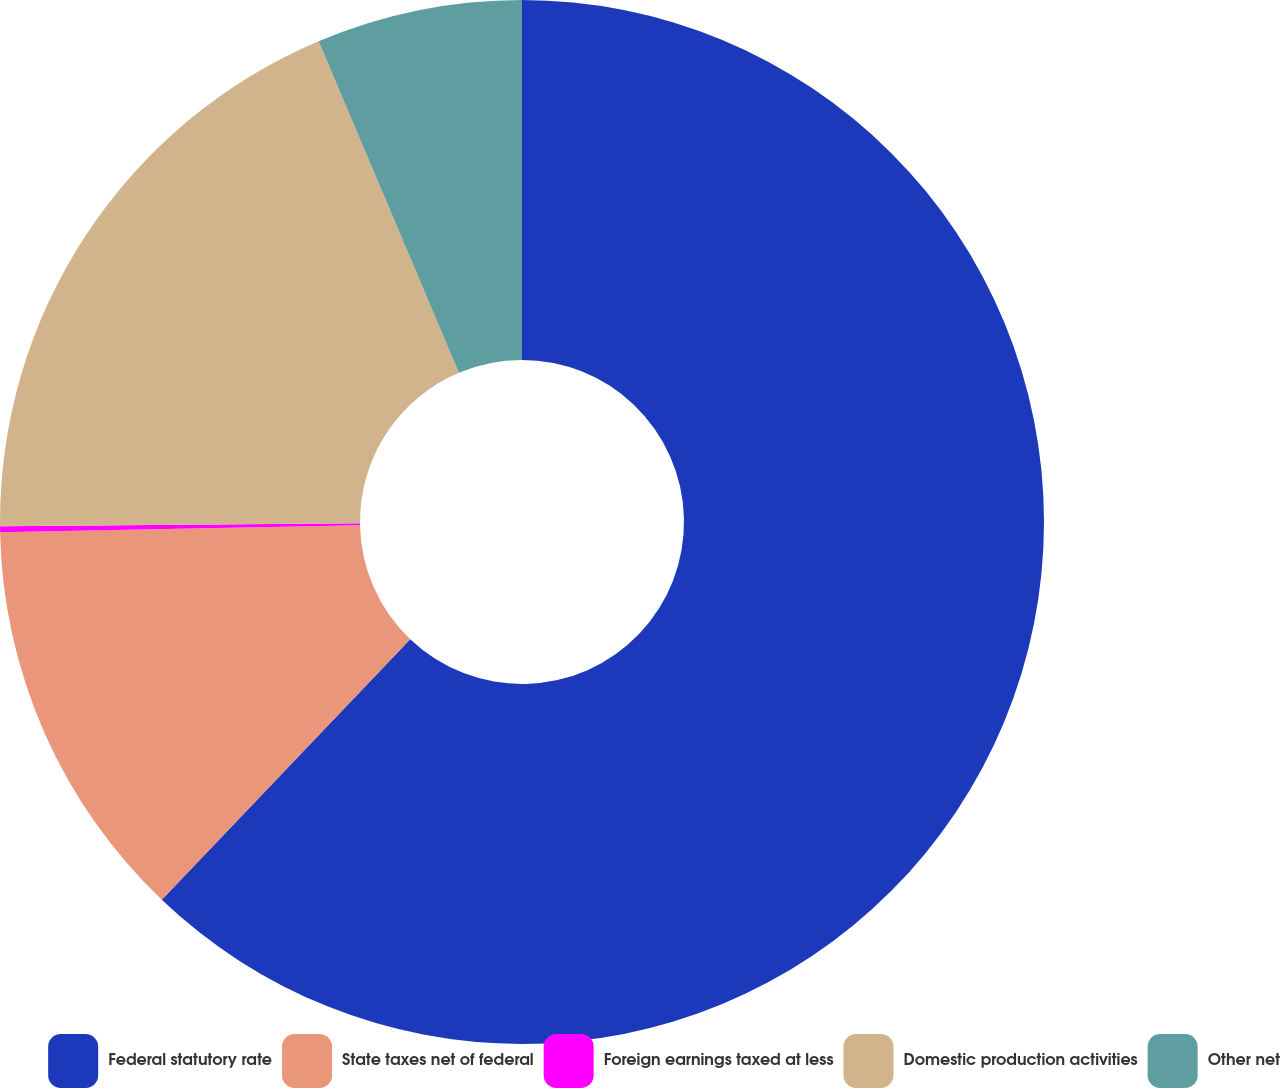Convert chart. <chart><loc_0><loc_0><loc_500><loc_500><pie_chart><fcel>Federal statutory rate<fcel>State taxes net of federal<fcel>Foreign earnings taxed at less<fcel>Domestic production activities<fcel>Other net<nl><fcel>62.12%<fcel>12.57%<fcel>0.18%<fcel>18.76%<fcel>6.37%<nl></chart> 